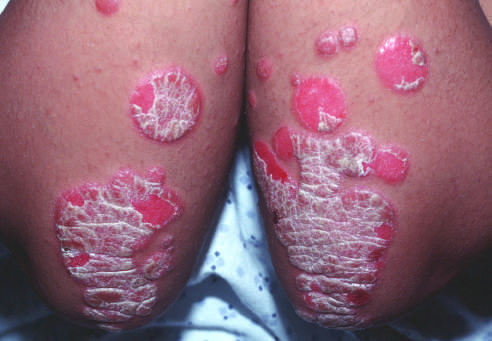re areas of chalky necrosis covered by silvery-white scale?
Answer the question using a single word or phrase. No 